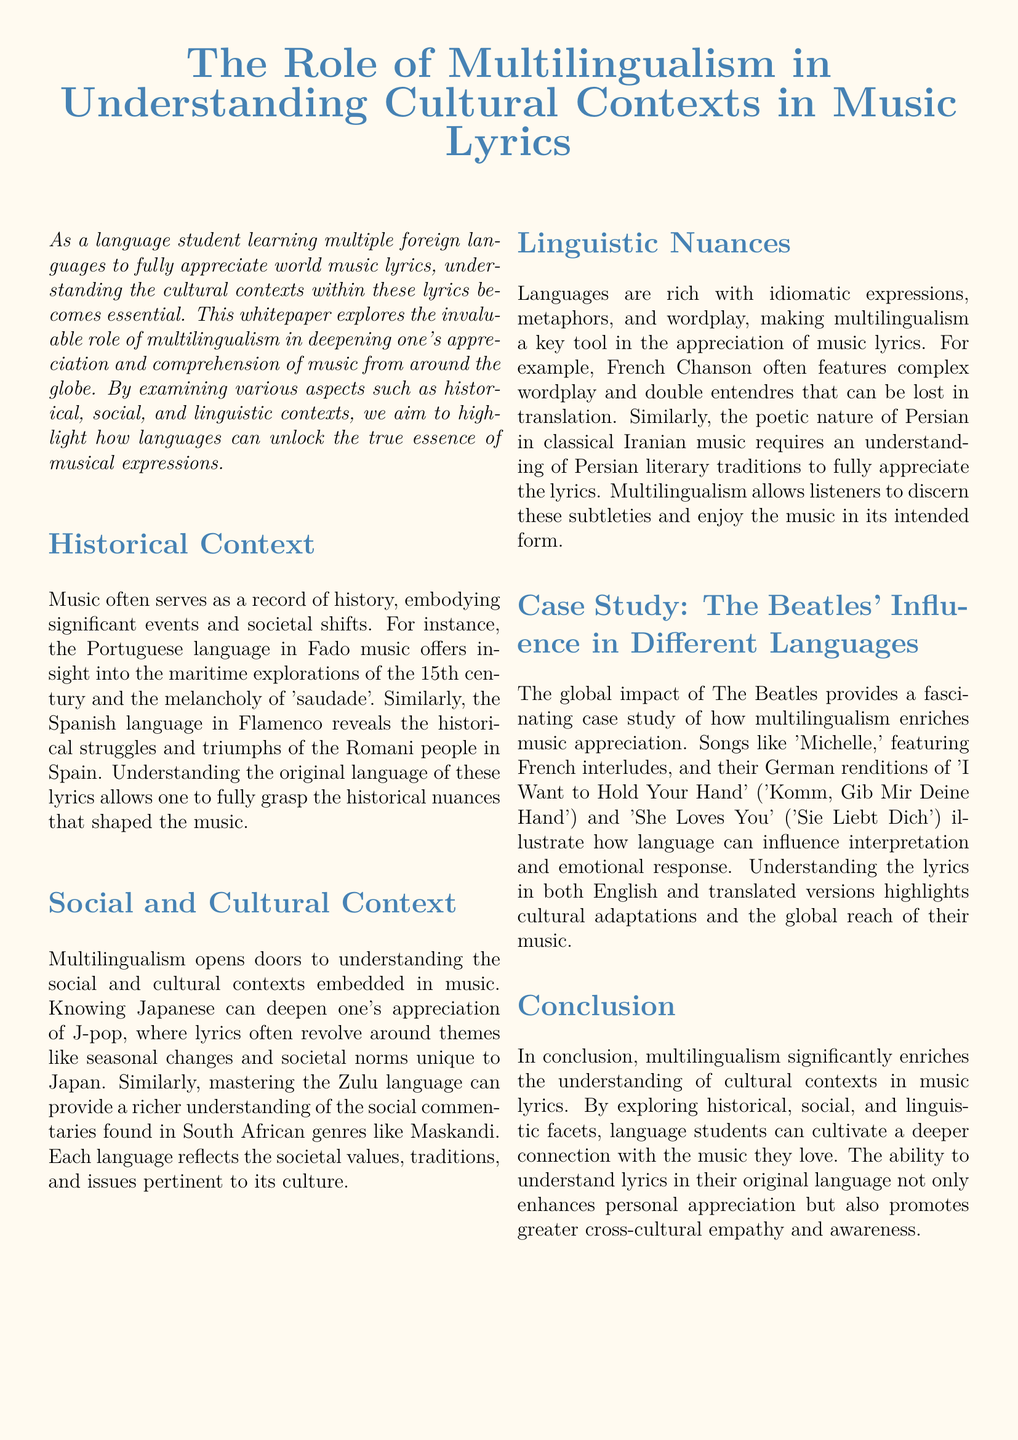What is the primary focus of the whitepaper? The whitepaper explores the role of multilingualism in understanding cultural contexts in music lyrics.
Answer: multilingualism in understanding cultural contexts in music lyrics What musical genre is associated with the Portuguese language in the document? The document mentions Fado music as the genre linked to the Portuguese language.
Answer: Fado Which social themes are often explored in J-pop lyrics? The document states that J-pop lyrics revolve around themes like seasonal changes and societal norms unique to Japan.
Answer: seasonal changes and societal norms What language is highlighted in the discussion about Machliess songs? The document discusses the importance of Zulu language in understanding South African genres.
Answer: Zulu Which famous band is used as a case study in the whitepaper? The whitepaper uses The Beatles as a case study to illustrate multilingualism in music.
Answer: The Beatles What is one linguistic aspect that enhances the appreciation of French Chanson? The document mentions complex wordplay as a key aspect in French Chanson that can be lost in translation.
Answer: complex wordplay How does multilingualism influence emotional response to music? Understanding the lyrics in both English and translated versions highlights cultural adaptations and influences emotional response.
Answer: cultural adaptations What literary tradition is essential for appreciating Persian music? The document states that understanding Persian literary traditions is essential for appreciating the poetic nature of classical Iranian music.
Answer: Persian literary traditions What does the conclusion emphasize about multilingualism in music comprehension? The conclusion highlights that multilingualism significantly enriches understanding of cultural contexts in music lyrics.
Answer: enriches understanding of cultural contexts in music lyrics 